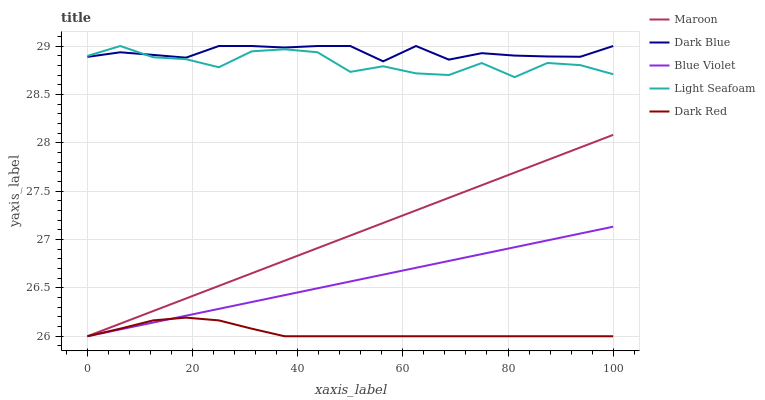Does Dark Red have the minimum area under the curve?
Answer yes or no. Yes. Does Dark Blue have the maximum area under the curve?
Answer yes or no. Yes. Does Light Seafoam have the minimum area under the curve?
Answer yes or no. No. Does Light Seafoam have the maximum area under the curve?
Answer yes or no. No. Is Maroon the smoothest?
Answer yes or no. Yes. Is Light Seafoam the roughest?
Answer yes or no. Yes. Is Blue Violet the smoothest?
Answer yes or no. No. Is Blue Violet the roughest?
Answer yes or no. No. Does Blue Violet have the lowest value?
Answer yes or no. Yes. Does Light Seafoam have the lowest value?
Answer yes or no. No. Does Light Seafoam have the highest value?
Answer yes or no. Yes. Does Blue Violet have the highest value?
Answer yes or no. No. Is Maroon less than Dark Blue?
Answer yes or no. Yes. Is Light Seafoam greater than Blue Violet?
Answer yes or no. Yes. Does Dark Red intersect Blue Violet?
Answer yes or no. Yes. Is Dark Red less than Blue Violet?
Answer yes or no. No. Is Dark Red greater than Blue Violet?
Answer yes or no. No. Does Maroon intersect Dark Blue?
Answer yes or no. No. 